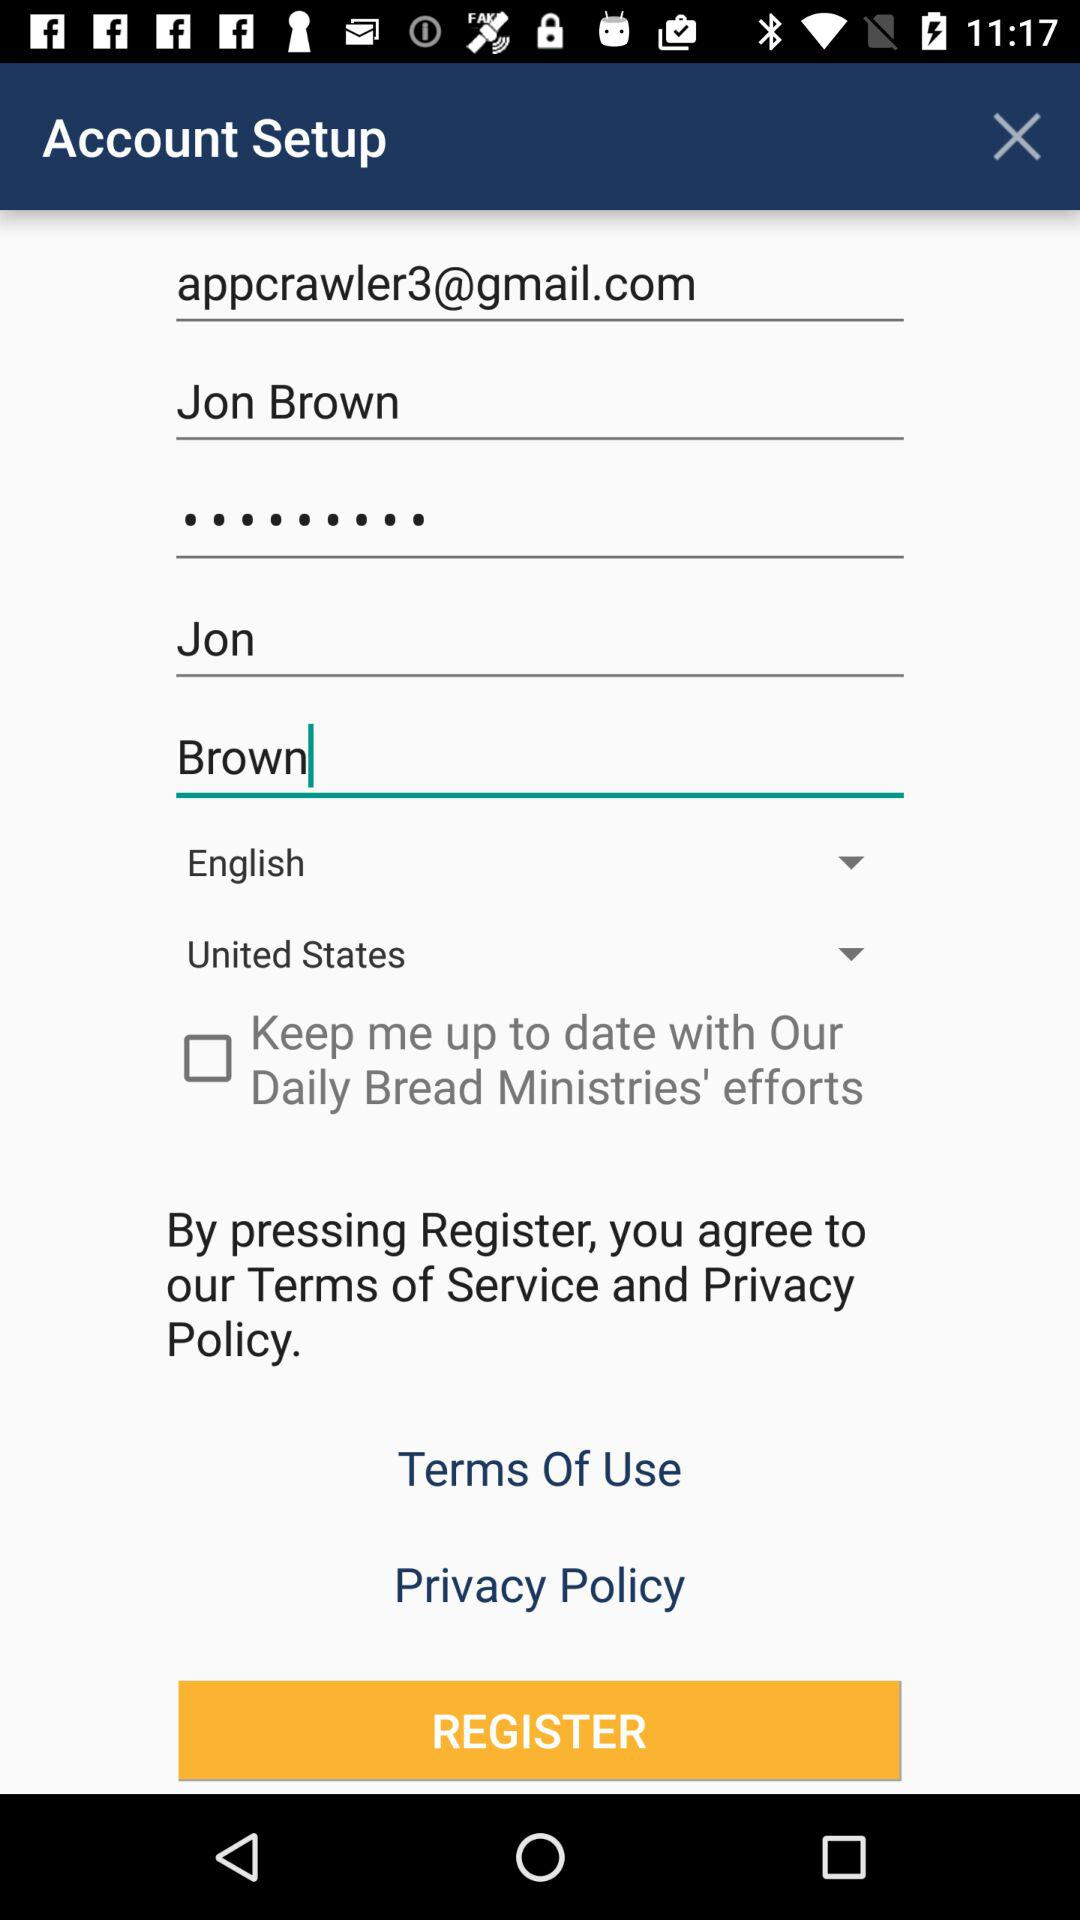What is the email address? The email address is appcrawler3@gmail.com. 